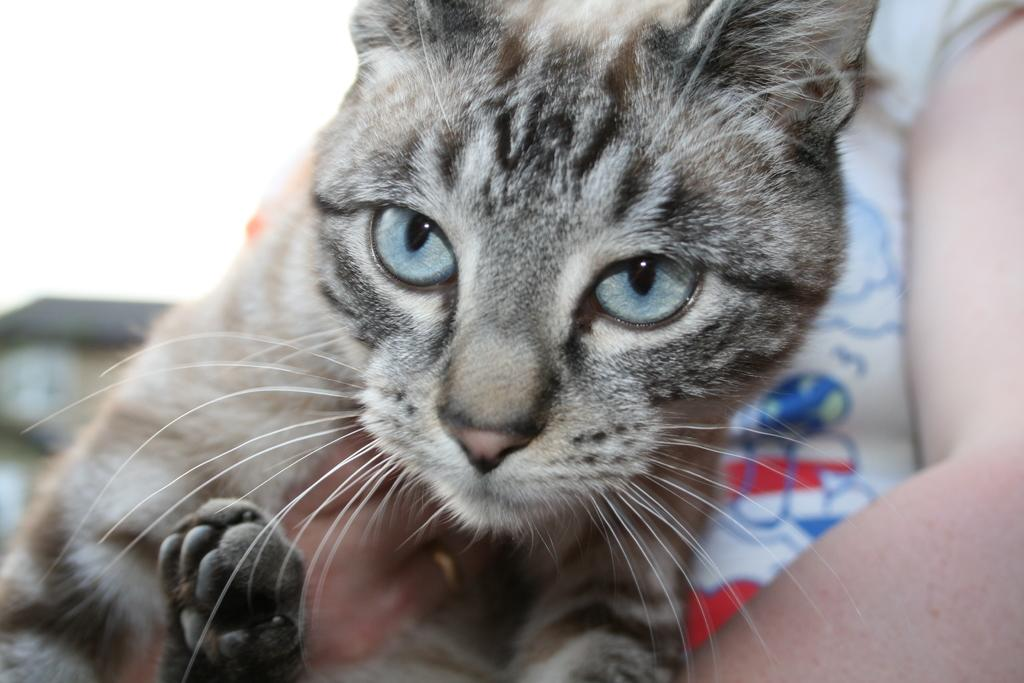What type of animal is present in the image? There is a cat in the image. Can you describe any human presence in the image? There is a hand of a person in the image. What type of grain can be seen growing on the farm in the image? There is no farm or grain present in the image; it features a cat and a hand of a person. What kind of trouble is the cat causing in the image? There is no indication of the cat causing any trouble in the image. 